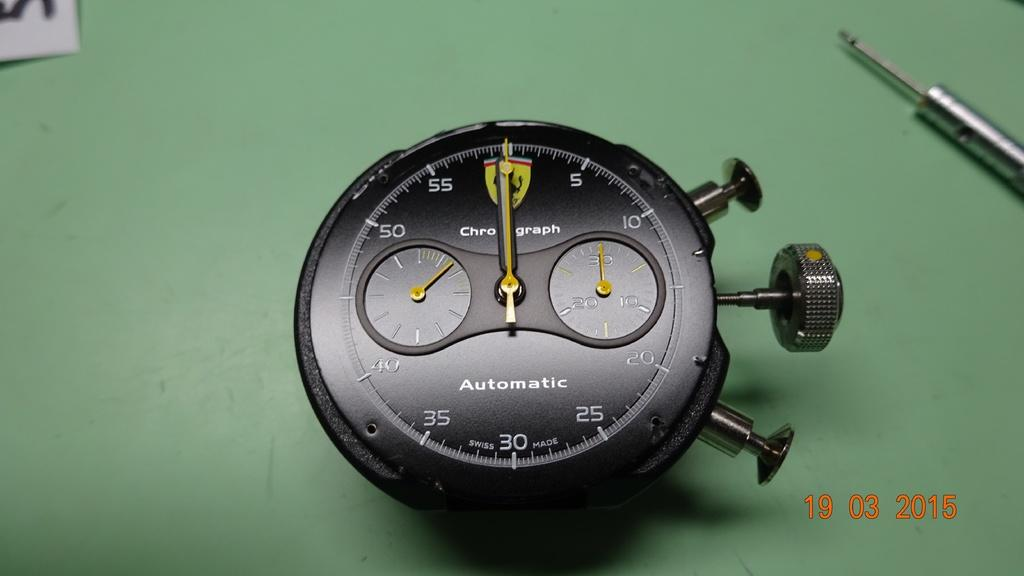Provide a one-sentence caption for the provided image. An automatic gauge, removed for closer inspection on a green surface. 